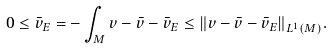<formula> <loc_0><loc_0><loc_500><loc_500>0 \leq \bar { v } _ { E } = - \int _ { M } v - \bar { v } - \bar { v } _ { E } \leq \| v - \bar { v } - \bar { v } _ { E } \| _ { L ^ { 1 } ( M ) } .</formula> 